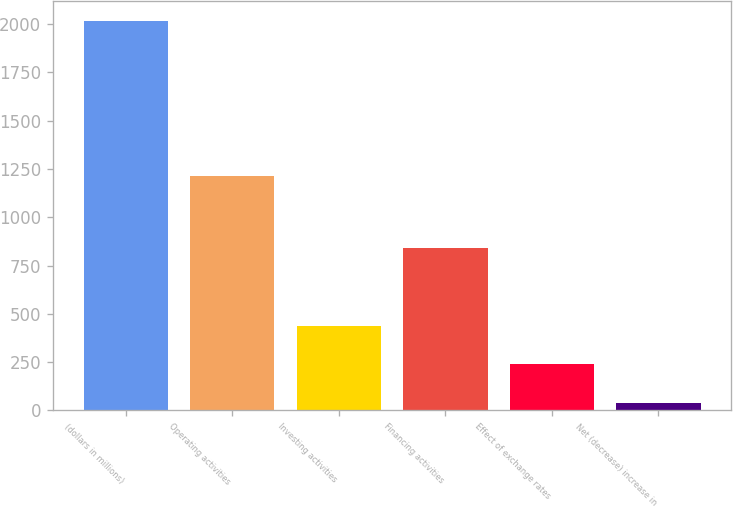<chart> <loc_0><loc_0><loc_500><loc_500><bar_chart><fcel>(dollars in millions)<fcel>Operating activities<fcel>Investing activities<fcel>Financing activities<fcel>Effect of exchange rates<fcel>Net (decrease) increase in<nl><fcel>2016<fcel>1211<fcel>436<fcel>843<fcel>238.5<fcel>41<nl></chart> 